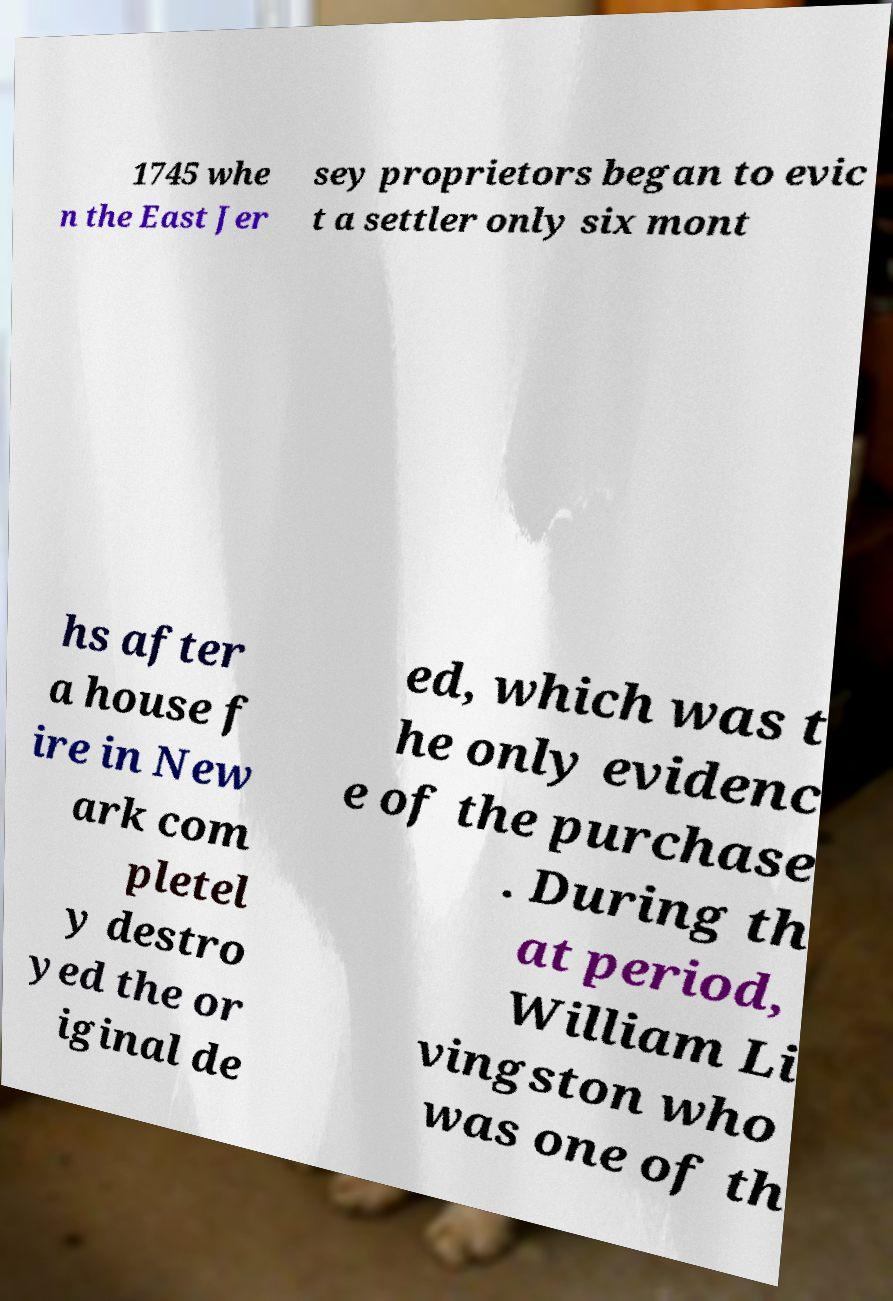Can you read and provide the text displayed in the image?This photo seems to have some interesting text. Can you extract and type it out for me? 1745 whe n the East Jer sey proprietors began to evic t a settler only six mont hs after a house f ire in New ark com pletel y destro yed the or iginal de ed, which was t he only evidenc e of the purchase . During th at period, William Li vingston who was one of th 